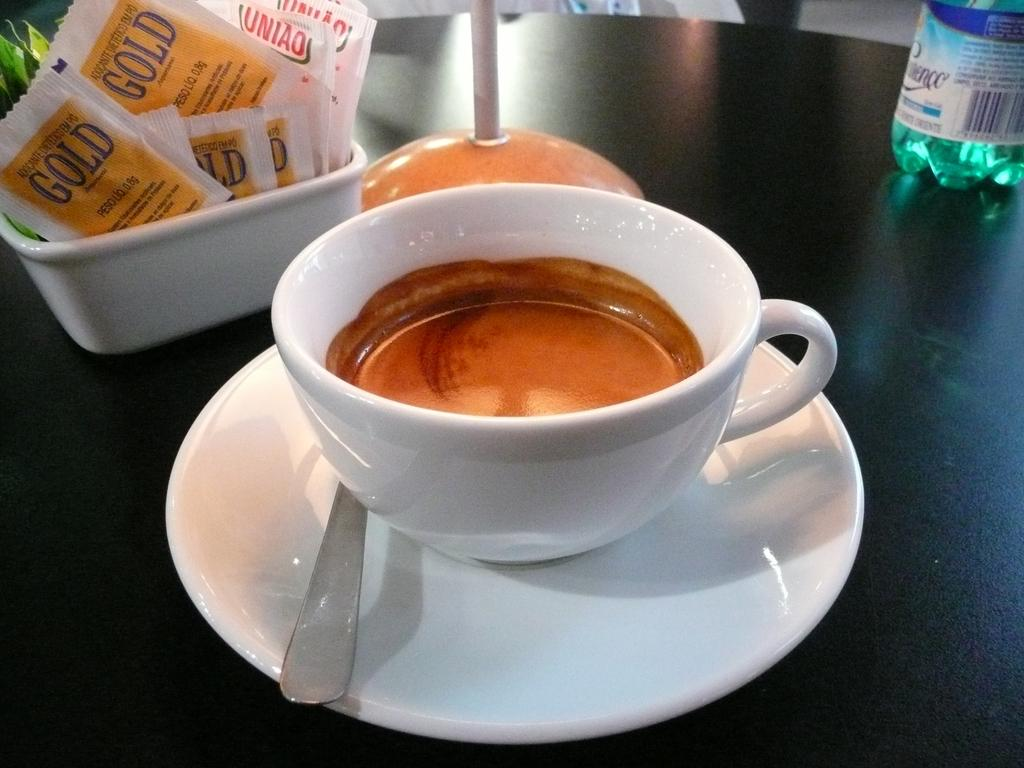What is placed on the table in the image? There is a cup, a saucer, a spoon, a water bottle, and a bowl of sachets on the table. What might be used for stirring or scooping in the image? The spoon on the table can be used for stirring or scooping. What is the purpose of the saucer in the image? The saucer is likely used to hold the cup and catch any spills or drips. What is contained in the bowl on the table? The bowl on the table contains sachets. What type of argument is taking place between the achiever and the holiday in the image? There is no achiever or holiday present in the image; it only features a cup, saucer, spoon, water bottle, and bowl of sachets on a table. 